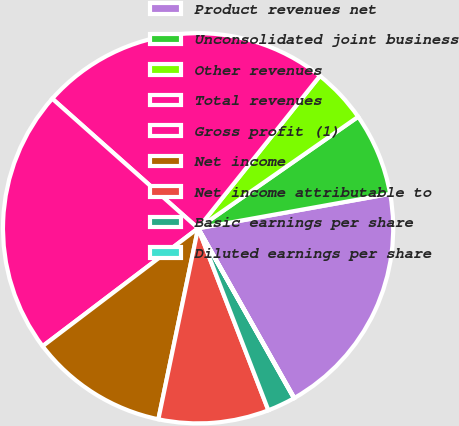Convert chart. <chart><loc_0><loc_0><loc_500><loc_500><pie_chart><fcel>Product revenues net<fcel>Unconsolidated joint business<fcel>Other revenues<fcel>Total revenues<fcel>Gross profit (1)<fcel>Net income<fcel>Net income attributable to<fcel>Basic earnings per share<fcel>Diluted earnings per share<nl><fcel>19.62%<fcel>6.86%<fcel>4.58%<fcel>24.17%<fcel>21.89%<fcel>11.41%<fcel>9.13%<fcel>2.31%<fcel>0.03%<nl></chart> 